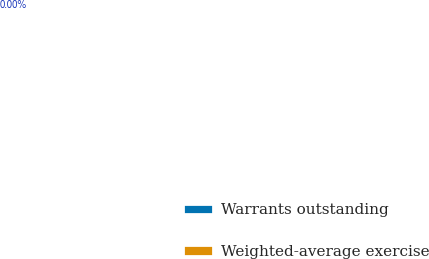Convert chart. <chart><loc_0><loc_0><loc_500><loc_500><pie_chart><fcel>Warrants outstanding<fcel>Weighted-average exercise<nl><fcel>100.0%<fcel>0.0%<nl></chart> 